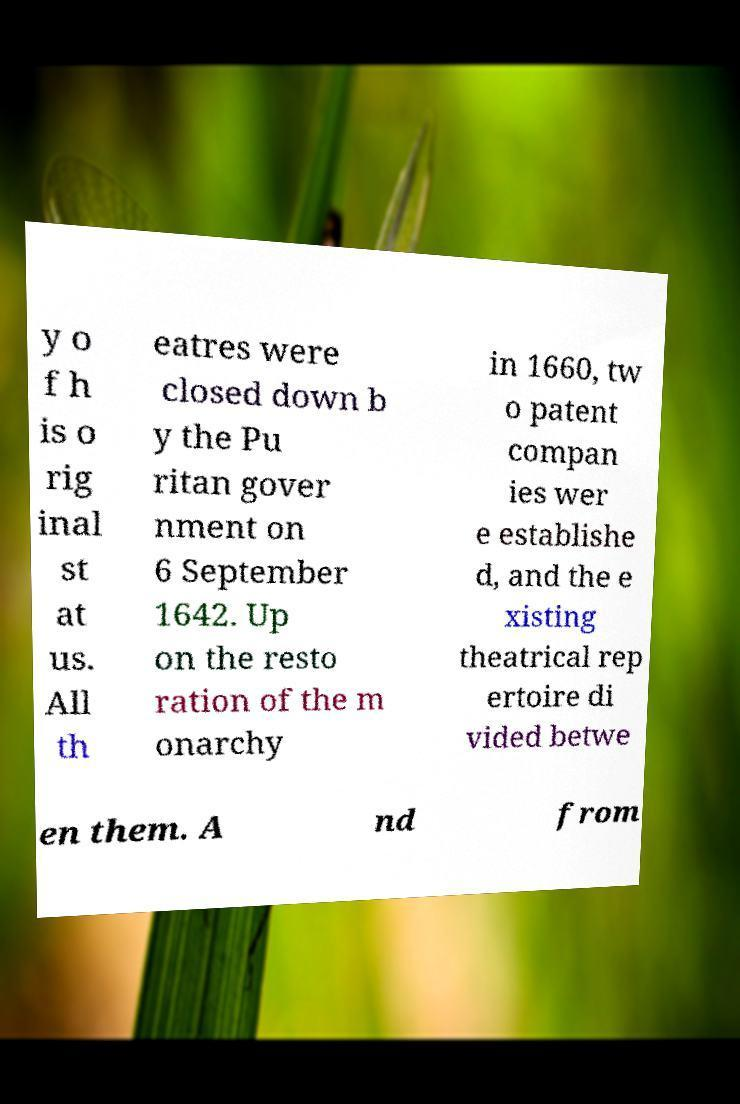Could you assist in decoding the text presented in this image and type it out clearly? y o f h is o rig inal st at us. All th eatres were closed down b y the Pu ritan gover nment on 6 September 1642. Up on the resto ration of the m onarchy in 1660, tw o patent compan ies wer e establishe d, and the e xisting theatrical rep ertoire di vided betwe en them. A nd from 